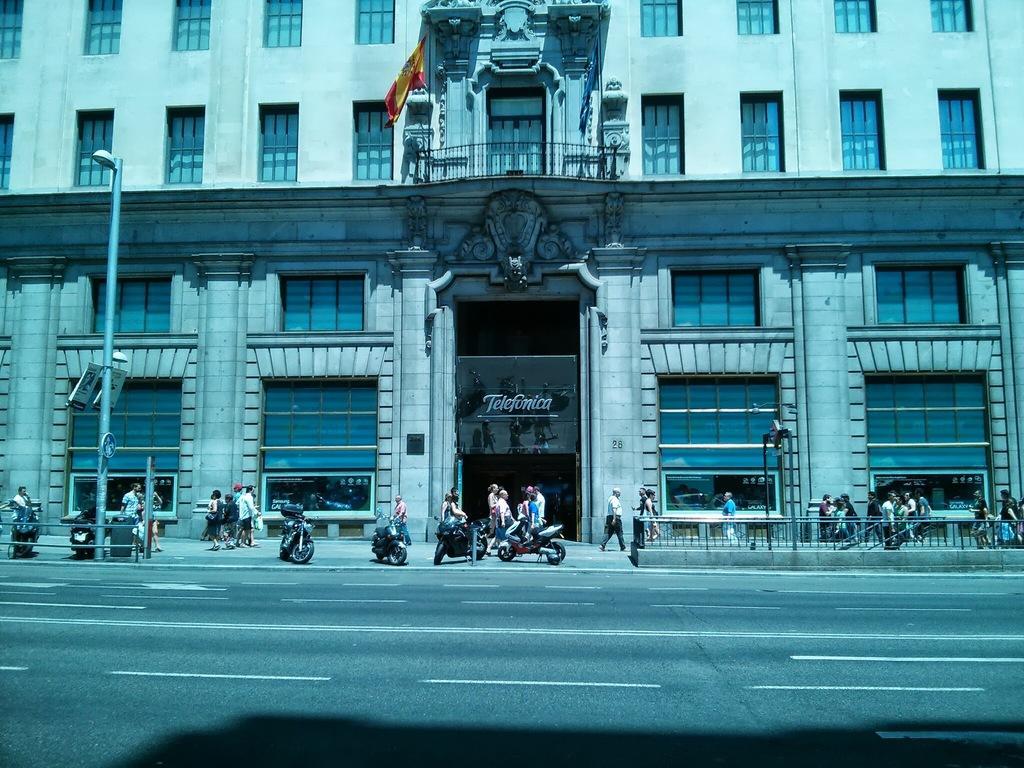Could you give a brief overview of what you see in this image? In this image there is a building at middle of this image and there is a flag in top of this image and and there is one pole at left side of this image and there are some persons and there are some bikes at bottom of this image and there is a road at below of this image. 